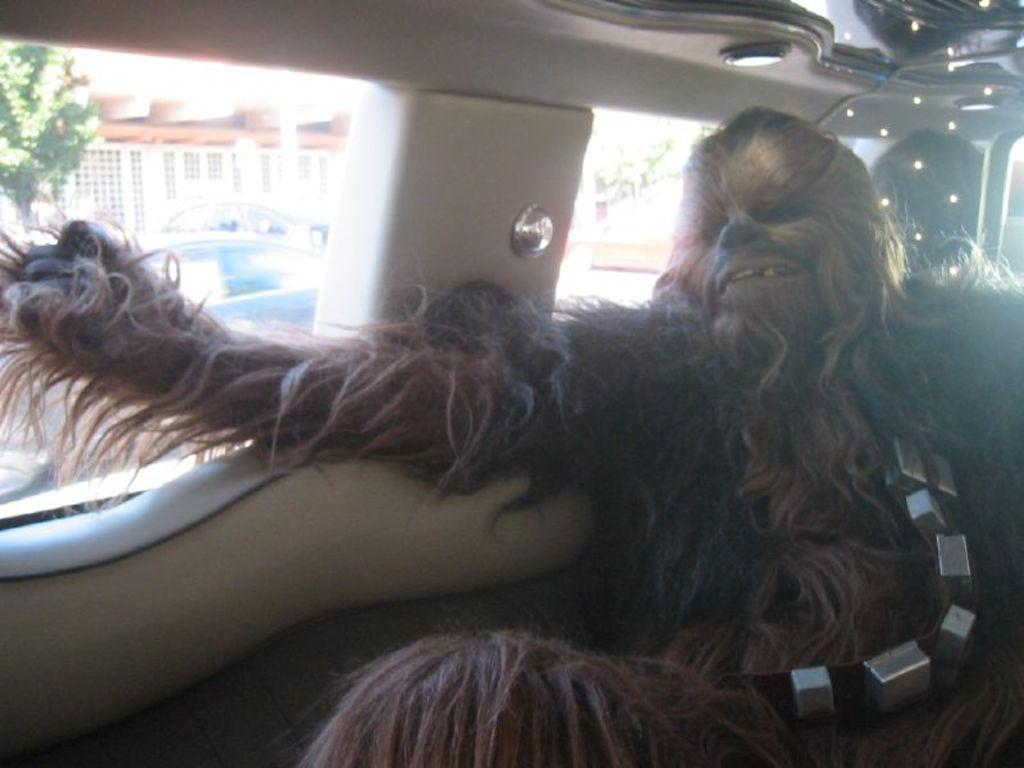What character is present in the image? There is a brown-colored Chewbacca in the image. Where is Chewbacca located in the image? Chewbacca is sitting in a car. What expression does Chewbacca have in the image? Chewbacca is smiling. What can be seen in the background of the image? There is a white building and a tree in the background of the image. What type of lock is holding Chewbacca's mind in the image? There is no lock or reference to Chewbacca's mind in the image; it simply shows Chewbacca sitting in a car and smiling. 